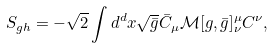Convert formula to latex. <formula><loc_0><loc_0><loc_500><loc_500>S _ { g h } = - \sqrt { 2 } \int d ^ { d } x \sqrt { \bar { g } } \bar { C } _ { \mu } \mathcal { M } [ g , \bar { g } ] ^ { \mu } _ { \nu } C ^ { \nu } ,</formula> 